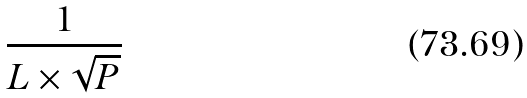<formula> <loc_0><loc_0><loc_500><loc_500>\frac { 1 } { L \times \sqrt { P } }</formula> 